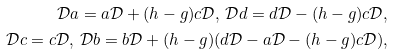<formula> <loc_0><loc_0><loc_500><loc_500>\mathcal { D } a = a \mathcal { D } + ( h - g ) c \mathcal { D } , \, \mathcal { D } d = d \mathcal { D } - ( h - g ) c \mathcal { D } , \\ \mathcal { D } c = c \mathcal { D } , \, \mathcal { D } b = b \mathcal { D } + ( h - g ) ( d \mathcal { D } - a \mathcal { D } - ( h - g ) c \mathcal { D } ) ,</formula> 